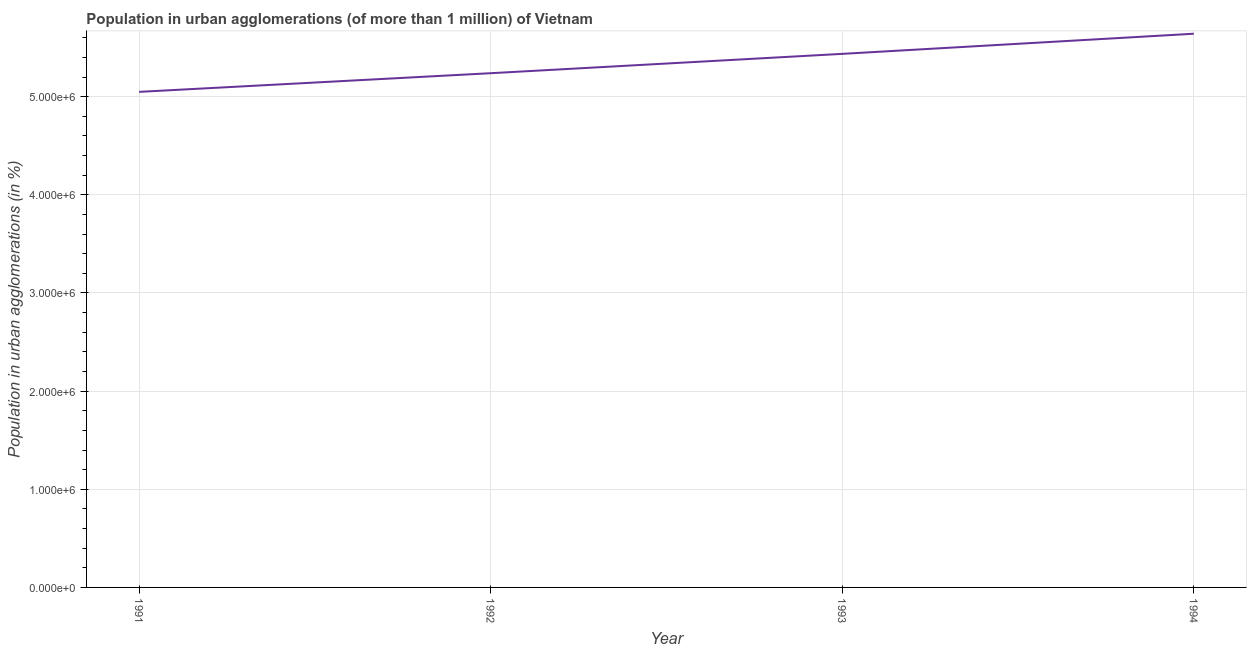What is the population in urban agglomerations in 1993?
Provide a succinct answer. 5.44e+06. Across all years, what is the maximum population in urban agglomerations?
Your response must be concise. 5.64e+06. Across all years, what is the minimum population in urban agglomerations?
Ensure brevity in your answer.  5.05e+06. What is the sum of the population in urban agglomerations?
Offer a very short reply. 2.14e+07. What is the difference between the population in urban agglomerations in 1993 and 1994?
Offer a terse response. -2.05e+05. What is the average population in urban agglomerations per year?
Offer a very short reply. 5.34e+06. What is the median population in urban agglomerations?
Offer a very short reply. 5.34e+06. In how many years, is the population in urban agglomerations greater than 2800000 %?
Keep it short and to the point. 4. Do a majority of the years between 1993 and 1992 (inclusive) have population in urban agglomerations greater than 3200000 %?
Your response must be concise. No. What is the ratio of the population in urban agglomerations in 1991 to that in 1993?
Offer a terse response. 0.93. Is the population in urban agglomerations in 1991 less than that in 1994?
Give a very brief answer. Yes. Is the difference between the population in urban agglomerations in 1991 and 1992 greater than the difference between any two years?
Your answer should be very brief. No. What is the difference between the highest and the second highest population in urban agglomerations?
Ensure brevity in your answer.  2.05e+05. What is the difference between the highest and the lowest population in urban agglomerations?
Give a very brief answer. 5.92e+05. How many lines are there?
Ensure brevity in your answer.  1. Are the values on the major ticks of Y-axis written in scientific E-notation?
Provide a succinct answer. Yes. What is the title of the graph?
Ensure brevity in your answer.  Population in urban agglomerations (of more than 1 million) of Vietnam. What is the label or title of the X-axis?
Your answer should be compact. Year. What is the label or title of the Y-axis?
Your answer should be compact. Population in urban agglomerations (in %). What is the Population in urban agglomerations (in %) of 1991?
Offer a very short reply. 5.05e+06. What is the Population in urban agglomerations (in %) of 1992?
Offer a terse response. 5.24e+06. What is the Population in urban agglomerations (in %) of 1993?
Ensure brevity in your answer.  5.44e+06. What is the Population in urban agglomerations (in %) of 1994?
Your answer should be compact. 5.64e+06. What is the difference between the Population in urban agglomerations (in %) in 1991 and 1992?
Your answer should be very brief. -1.90e+05. What is the difference between the Population in urban agglomerations (in %) in 1991 and 1993?
Provide a short and direct response. -3.87e+05. What is the difference between the Population in urban agglomerations (in %) in 1991 and 1994?
Your answer should be compact. -5.92e+05. What is the difference between the Population in urban agglomerations (in %) in 1992 and 1993?
Make the answer very short. -1.97e+05. What is the difference between the Population in urban agglomerations (in %) in 1992 and 1994?
Offer a terse response. -4.02e+05. What is the difference between the Population in urban agglomerations (in %) in 1993 and 1994?
Offer a very short reply. -2.05e+05. What is the ratio of the Population in urban agglomerations (in %) in 1991 to that in 1993?
Provide a succinct answer. 0.93. What is the ratio of the Population in urban agglomerations (in %) in 1991 to that in 1994?
Make the answer very short. 0.9. What is the ratio of the Population in urban agglomerations (in %) in 1992 to that in 1994?
Make the answer very short. 0.93. 